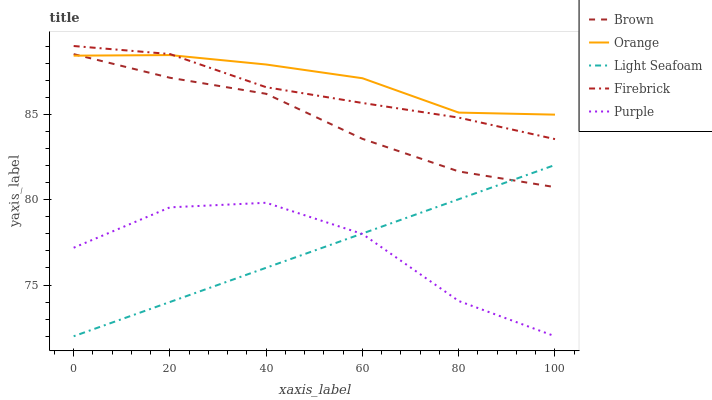Does Light Seafoam have the minimum area under the curve?
Answer yes or no. Yes. Does Orange have the maximum area under the curve?
Answer yes or no. Yes. Does Brown have the minimum area under the curve?
Answer yes or no. No. Does Brown have the maximum area under the curve?
Answer yes or no. No. Is Light Seafoam the smoothest?
Answer yes or no. Yes. Is Purple the roughest?
Answer yes or no. Yes. Is Brown the smoothest?
Answer yes or no. No. Is Brown the roughest?
Answer yes or no. No. Does Brown have the lowest value?
Answer yes or no. No. Does Firebrick have the highest value?
Answer yes or no. Yes. Does Brown have the highest value?
Answer yes or no. No. Is Purple less than Firebrick?
Answer yes or no. Yes. Is Firebrick greater than Brown?
Answer yes or no. Yes. Does Light Seafoam intersect Purple?
Answer yes or no. Yes. Is Light Seafoam less than Purple?
Answer yes or no. No. Is Light Seafoam greater than Purple?
Answer yes or no. No. Does Purple intersect Firebrick?
Answer yes or no. No. 